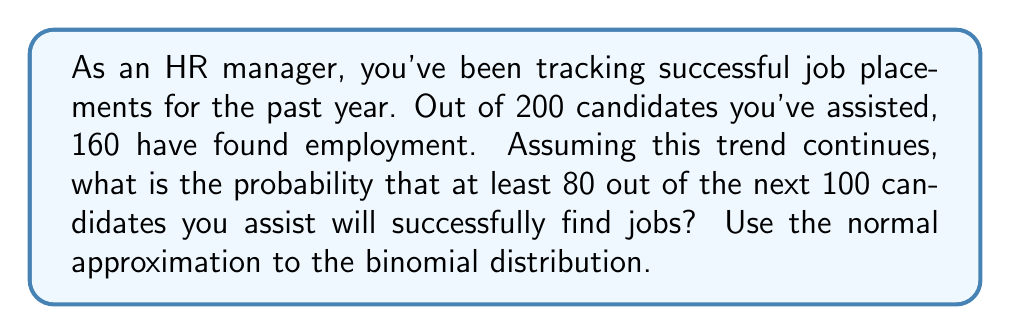Can you solve this math problem? Let's approach this step-by-step:

1) First, we need to calculate the probability of success (p) based on the given data:
   $p = \frac{160}{200} = 0.8$ or 80%

2) For the next 100 candidates, we want to find P(X ≥ 80), where X is the number of successful placements.

3) To use the normal approximation, we need to check if np and n(1-p) are both greater than 5:
   $np = 100 * 0.8 = 80$ and $n(1-p) = 100 * 0.2 = 20$
   Both are greater than 5, so we can proceed.

4) Calculate the mean (μ) and standard deviation (σ) of the normal approximation:
   $\mu = np = 100 * 0.8 = 80$
   $\sigma = \sqrt{np(1-p)} = \sqrt{100 * 0.8 * 0.2} = 4$

5) We need to find P(X ≥ 80). Using the continuity correction, this becomes P(X > 79.5).

6) Convert to a z-score:
   $z = \frac{79.5 - 80}{4} = -0.125$

7) We want P(Z > -0.125), which is equivalent to 1 - P(Z < -0.125)

8) Using a standard normal table or calculator, we find:
   P(Z < -0.125) ≈ 0.4503

9) Therefore, P(Z > -0.125) = 1 - 0.4503 = 0.5497

Thus, the probability of at least 80 out of the next 100 candidates finding jobs is approximately 0.5497 or 54.97%.
Answer: 0.5497 